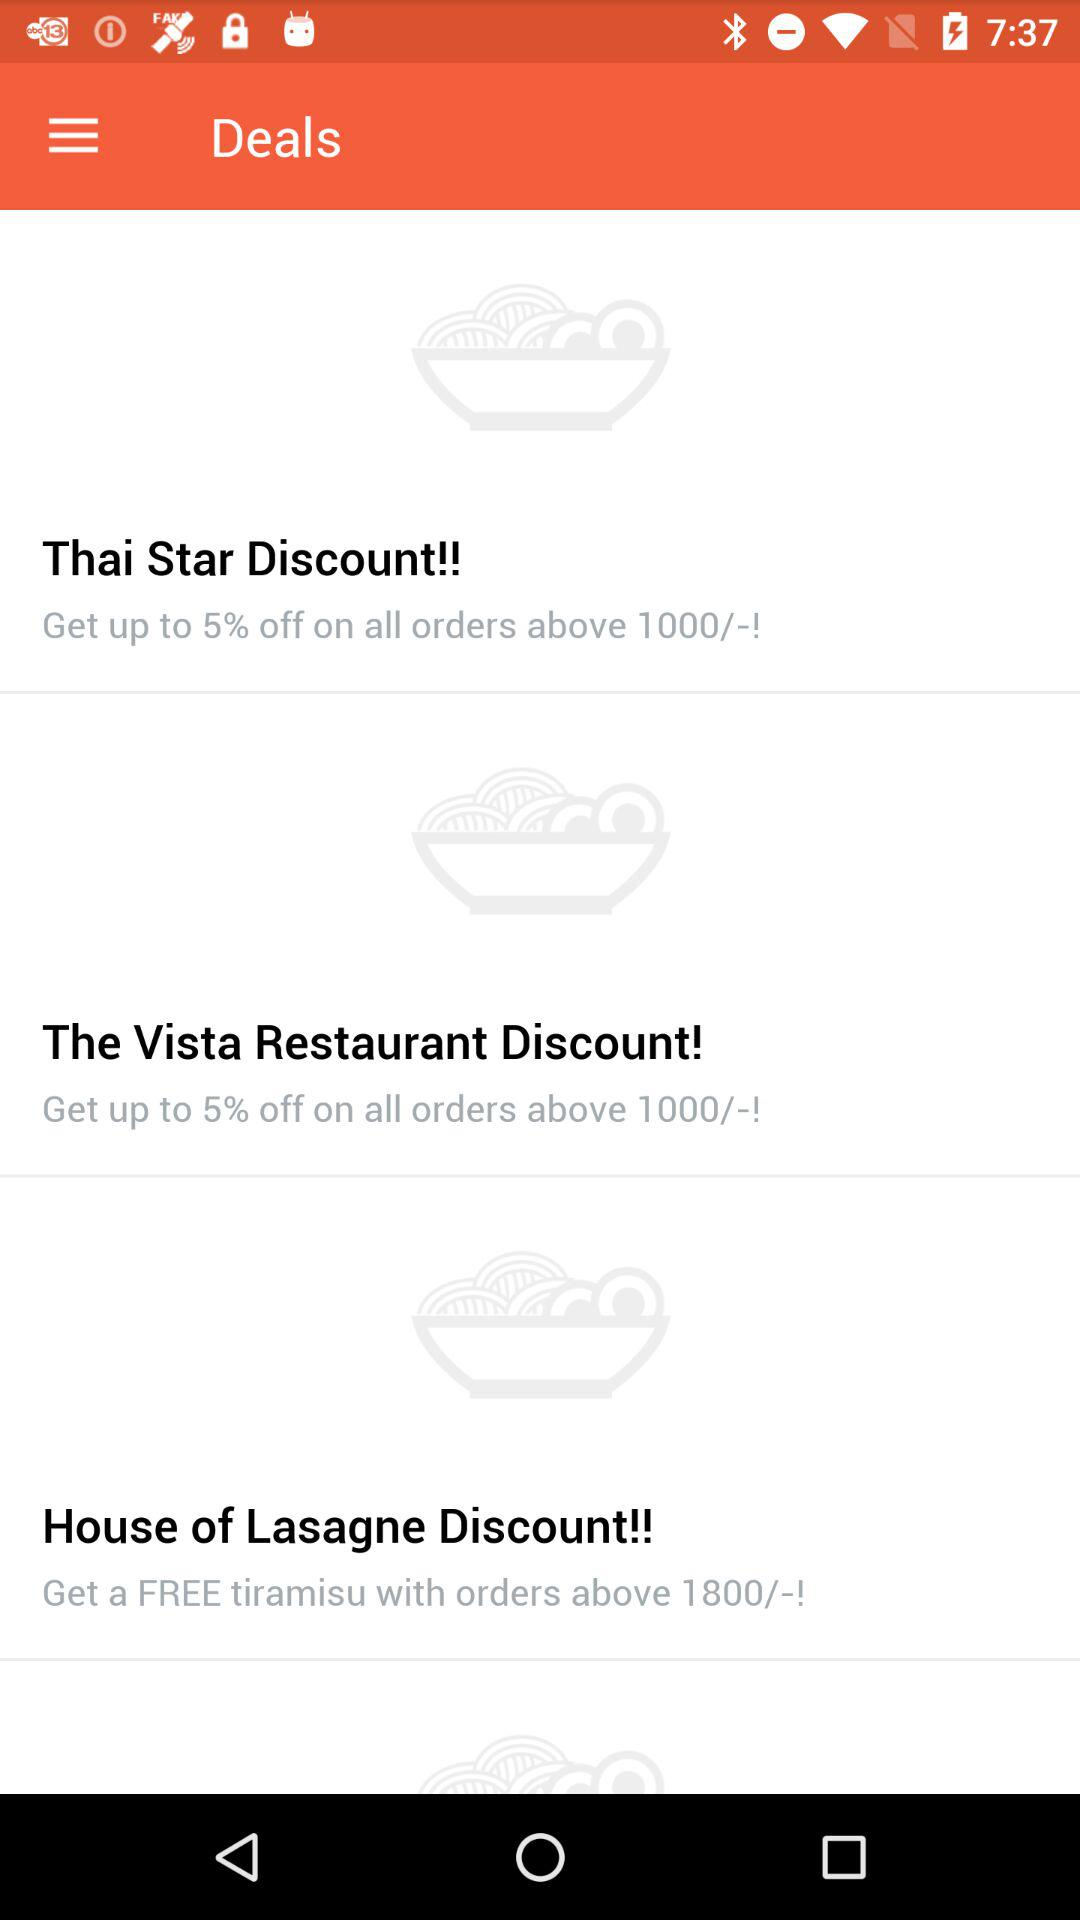How many discounts offer a discount of up to 5%?
Answer the question using a single word or phrase. 2 